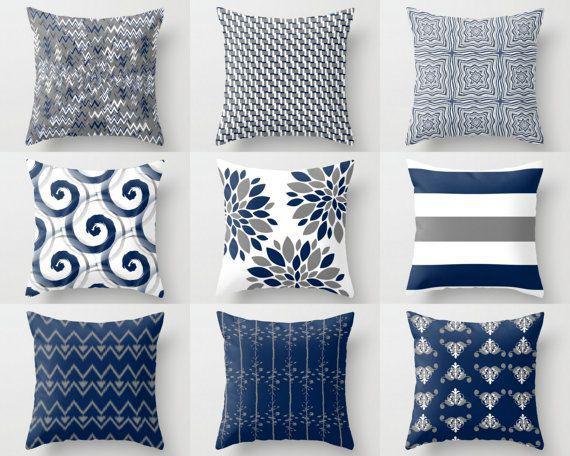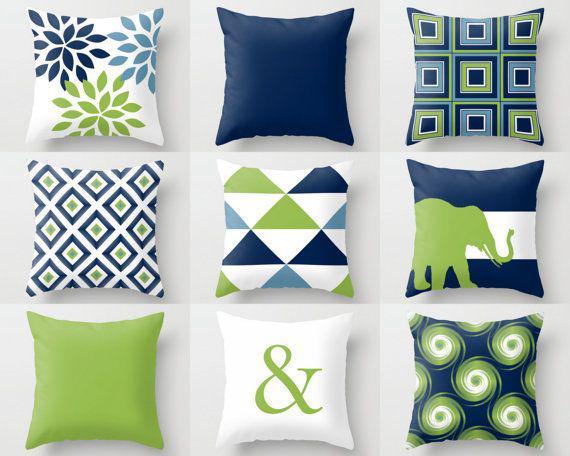The first image is the image on the left, the second image is the image on the right. Assess this claim about the two images: "There are five throw pillows in each picture on the left and two throw pillows in each picture on the right.". Correct or not? Answer yes or no. No. The first image is the image on the left, the second image is the image on the right. Analyze the images presented: Is the assertion "there are two throw pillows in the right image" valid? Answer yes or no. No. 